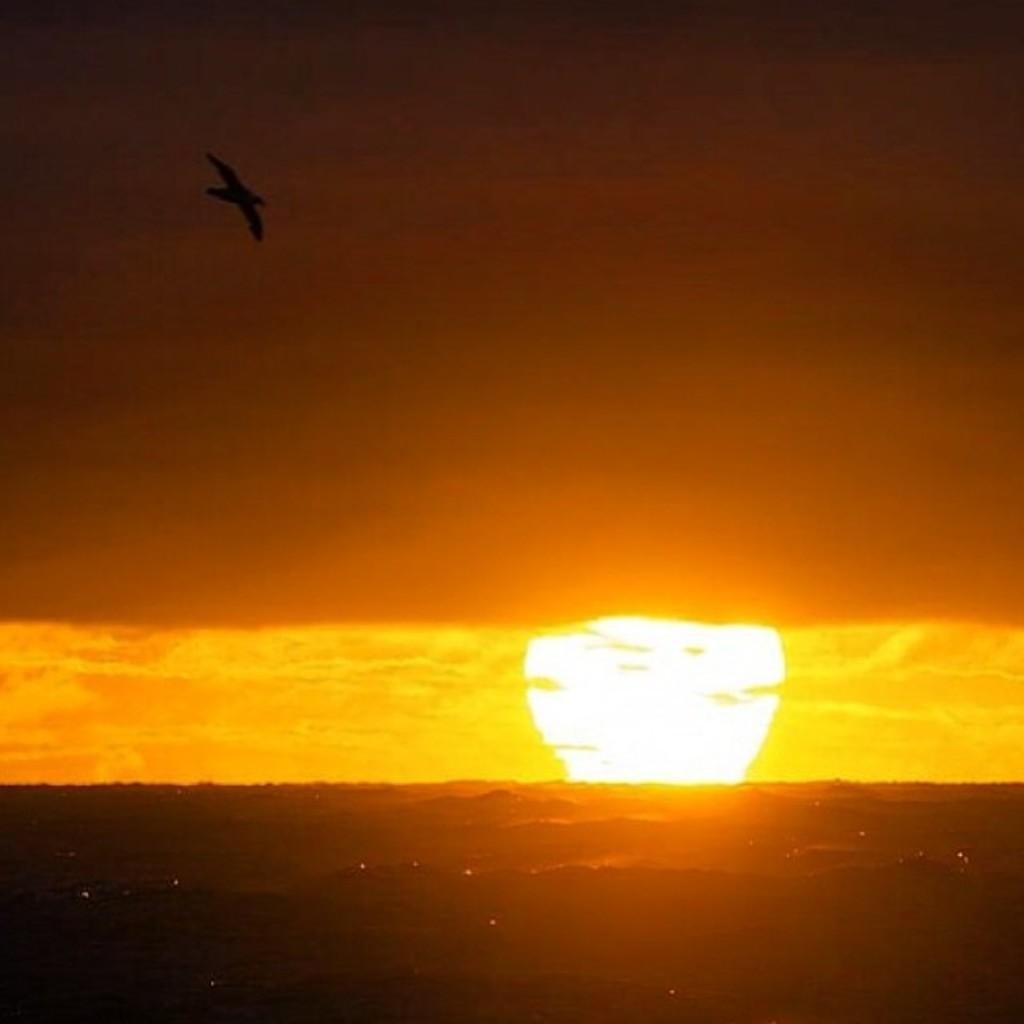How would you summarize this image in a sentence or two? In this image there is a bird flying in the sky , and in the background there is sun. 